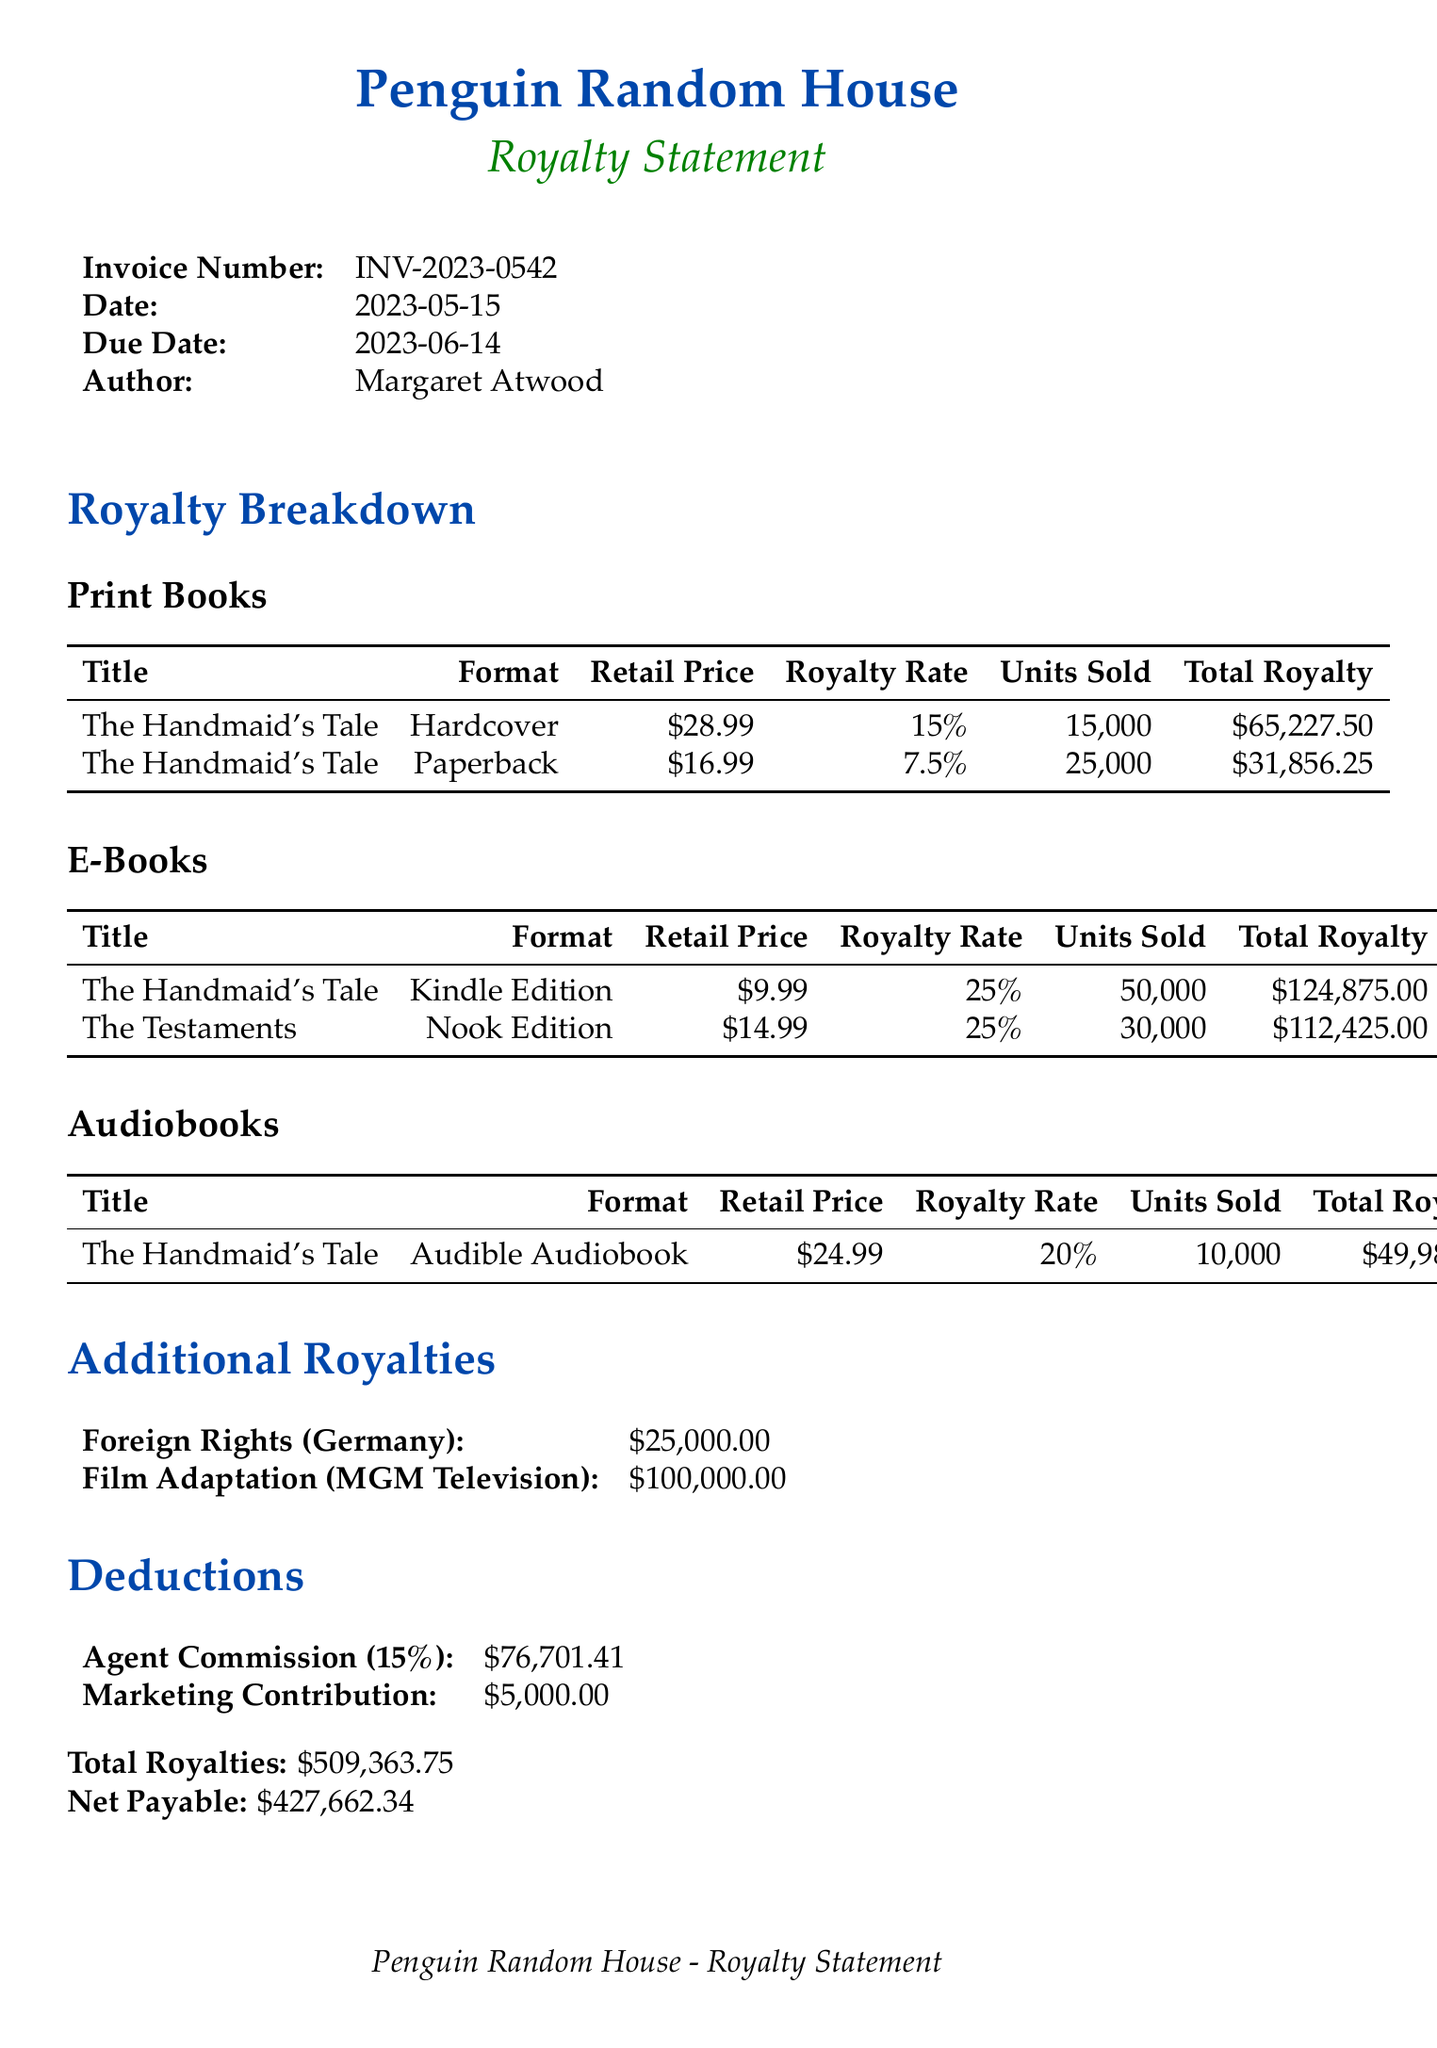what is the invoice number? The invoice number is located in the invoice details section of the document.
Answer: INV-2023-0542 who is the author? The author's name is mentioned directly in the invoice details.
Answer: Margaret Atwood how many units of the hardcover book were sold? The units sold for the hardcover book are found in the print books section of the royalty breakdown.
Answer: 15000 what is the total royalty for the e-book "The Testaments"? The total royalty for "The Testaments" is stated alongside its sales information in the e-books section.
Answer: 112425.00 what percentage is the agent's commission? The agent commission rate is indicated in the deductions section of the document.
Answer: 15% what is the net payable amount? The net payable amount is summarized at the end of the document under total royalties and net payable.
Answer: 427662.34 how much was contributed to the book drive? The contribution to the book drive is detailed specifically in the book drive contribution section.
Answer: 500 print books which bank is used for the payment method? The bank for the payment method is noted in the payment method portion of the document.
Answer: Royal Bank of Canada what event did the book drive contribution support? The event for the book drive is explicitly mentioned in the book drive contribution section.
Answer: Toronto Public Library Annual Book Drive 